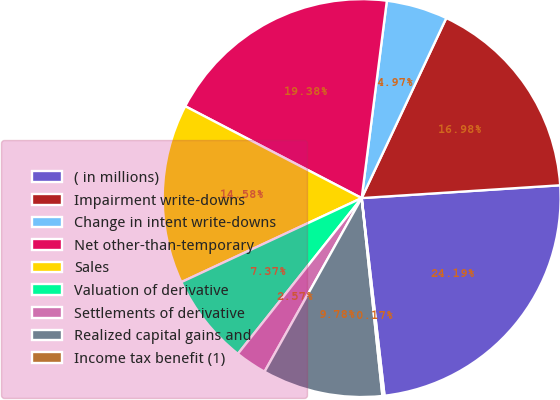Convert chart to OTSL. <chart><loc_0><loc_0><loc_500><loc_500><pie_chart><fcel>( in millions)<fcel>Impairment write-downs<fcel>Change in intent write-downs<fcel>Net other-than-temporary<fcel>Sales<fcel>Valuation of derivative<fcel>Settlements of derivative<fcel>Realized capital gains and<fcel>Income tax benefit (1)<nl><fcel>24.19%<fcel>16.98%<fcel>4.97%<fcel>19.38%<fcel>14.58%<fcel>7.37%<fcel>2.57%<fcel>9.78%<fcel>0.17%<nl></chart> 